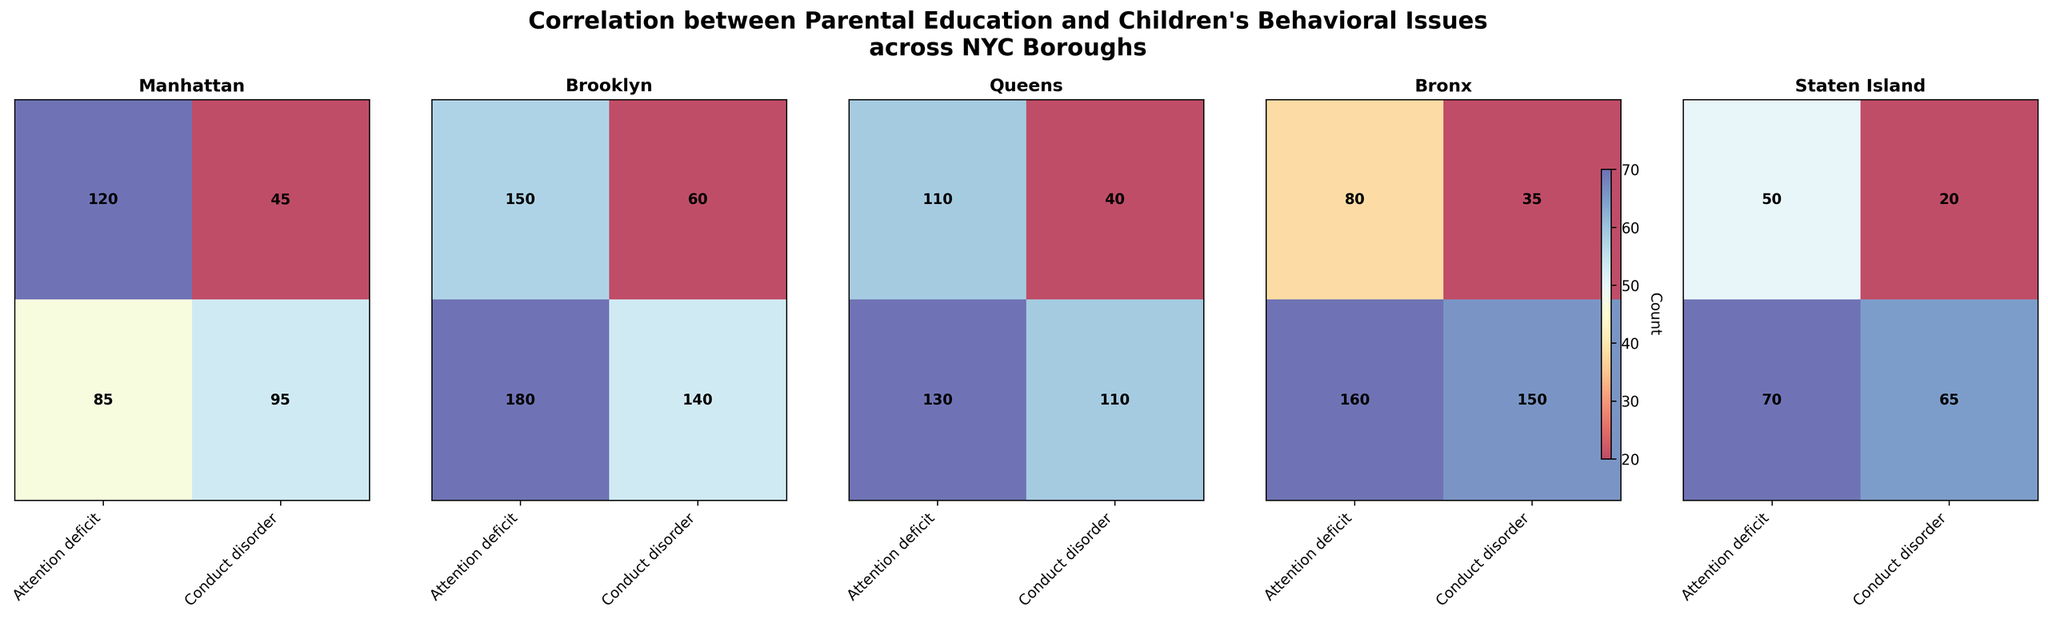How many categories of parental education levels are represented in the plot? Each borough has columns representing different parental education levels. By counting the distinct labels on the y-axis in the first subplot, you can see there are two categories.
Answer: 2 Which borough has the highest count of children with attention deficit whose parents have a high school education or less? Look at the plots for each borough and check the cell representing "Attention deficit" with the "High school or less" parental education. The Bronx has the highest count with 160.
Answer: The Bronx Compare the number of conduct disorder cases in Brooklyn between parents with college degrees or higher and those with high school education or less. Which group has more cases? In Brooklyn, refer to the row for conduct disorder. For college degrees or higher, the count is 60. For high school or less, the count is 140. Therefore, high school or less has more cases.
Answer: High school or less What is the total count of attention deficit cases in Manhattan? Sum the counts of attention deficit cases for both education levels in Manhattan; 120 (college degree or higher) + 85 (high school or less) equals 205.
Answer: 205 Does any borough have an equal count of attention deficit and conduct disorder cases under any parental education level? Compare the counts for attention deficit and conduct disorder within each educational level and borough. No pairs are equal in the dataset provided.
Answer: No Which borough shows the smallest difference between counts of attention deficit and conduct disorder for parents with college degrees or higher? Calculate the differences for each borough: 
    - Manhattan: 120 - 45 = 75
    - Brooklyn: 150 - 60 = 90
    - Queens: 110 - 40 = 70
    - Bronx: 80 - 35 = 45
    - Staten Island: 50 - 20 = 30
Staten Island has the smallest difference.
Answer: Staten Island What is the overall trend in behavioral issues based on parental education level across the NYC boroughs? For each borough, compare the behavior issue counts for each education level. Generally, children whose parents have a high school education or less have higher cases for both behavioral issues compared to those with college degrees or higher.
Answer: Higher issues with high school or less 